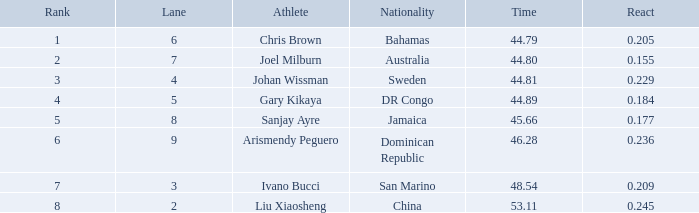How many total Time listings have a 0.209 React entry and a Rank that is greater than 7? 0.0. 